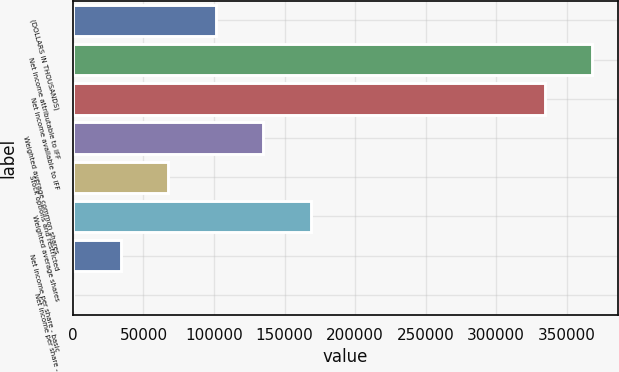Convert chart. <chart><loc_0><loc_0><loc_500><loc_500><bar_chart><fcel>(DOLLARS IN THOUSANDS)<fcel>Net income attributable to IFF<fcel>Net income available to IFF<fcel>Weighted average common shares<fcel>Stock options and restricted<fcel>Weighted average shares<fcel>Net income per share - basic<fcel>Net income per share -<nl><fcel>101193<fcel>368184<fcel>334454<fcel>134923<fcel>67463.4<fcel>168653<fcel>33733.6<fcel>3.79<nl></chart> 